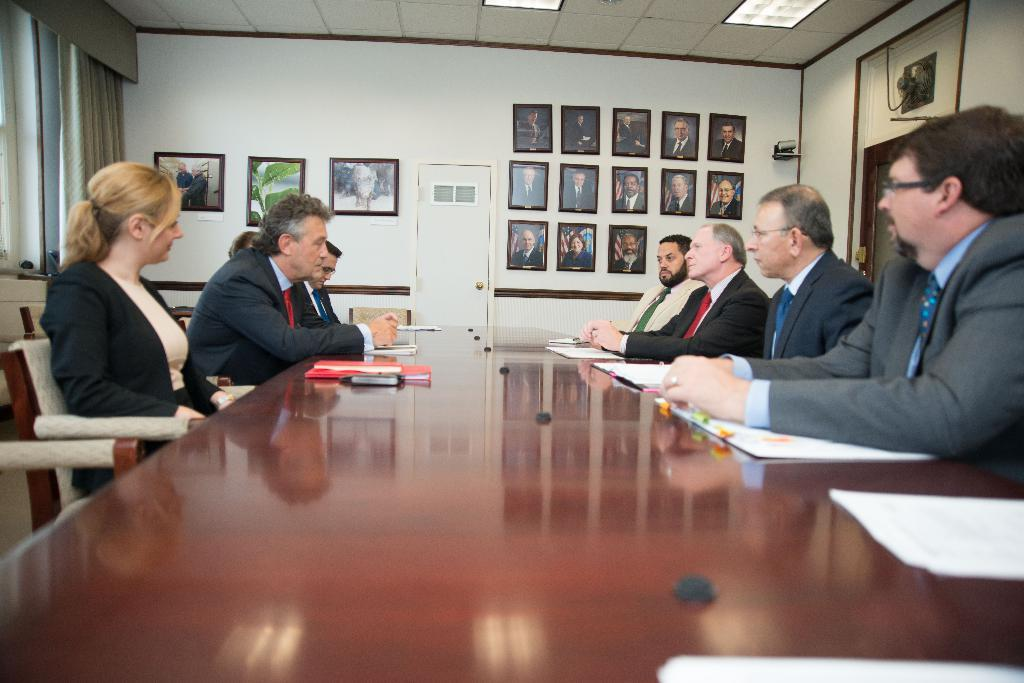How many people are in the image? There is a group of people in the image. What are the people doing in the image? The people are seated on chairs and facing each other. What can be seen on the wall in the image? There are photos of different people on the wall. What architectural features are present in the image? There is a door and a curtain in the image. What type of chalk is being used to draw on the door in the image? There is no chalk or drawing on the door in the image. How many wishes can be granted by the people in the image? There is no mention of wishes or granting wishes in the image. 